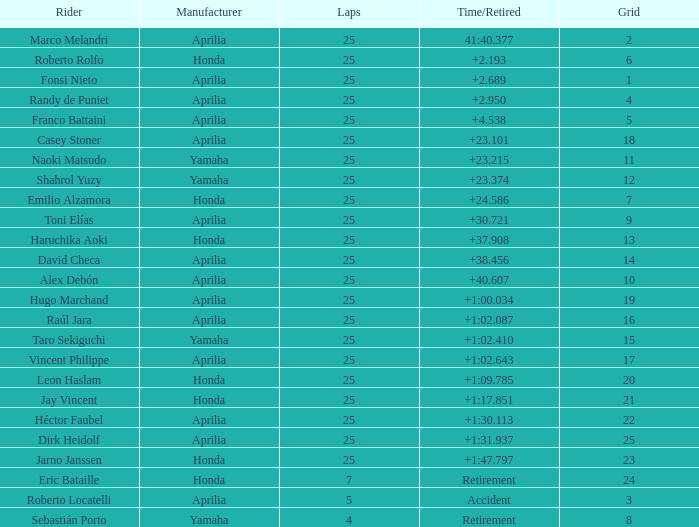Which Laps have a Time/Retired of +23.215, and a Grid larger than 11? None. 